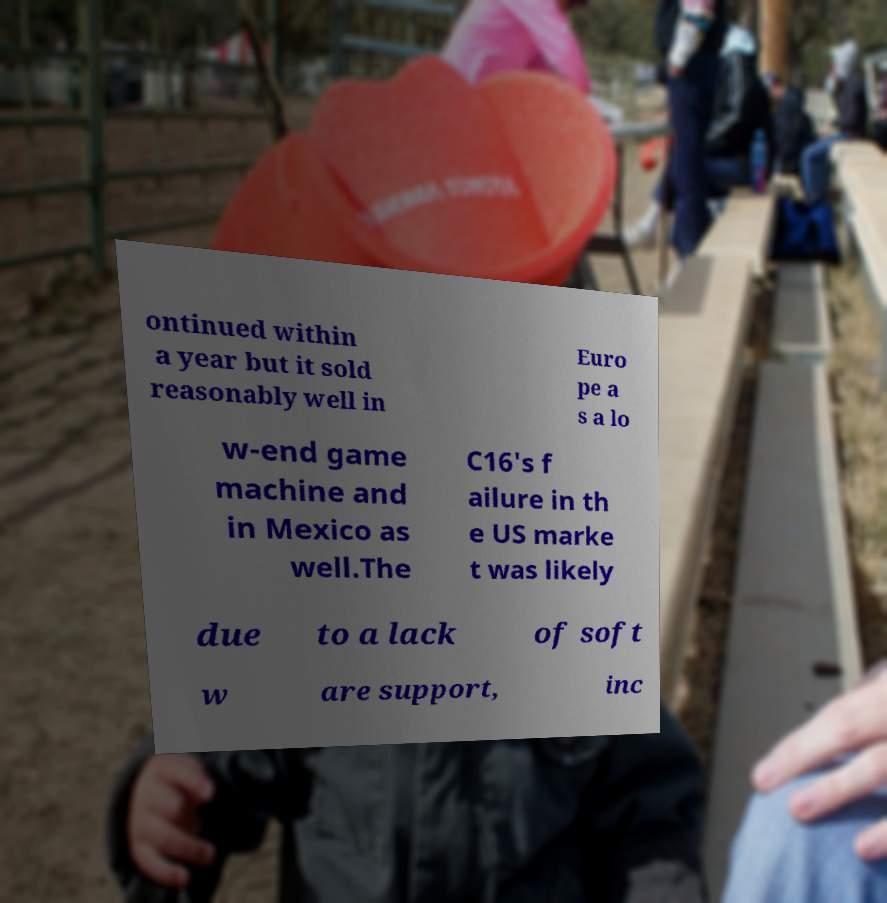Can you read and provide the text displayed in the image?This photo seems to have some interesting text. Can you extract and type it out for me? ontinued within a year but it sold reasonably well in Euro pe a s a lo w-end game machine and in Mexico as well.The C16's f ailure in th e US marke t was likely due to a lack of soft w are support, inc 